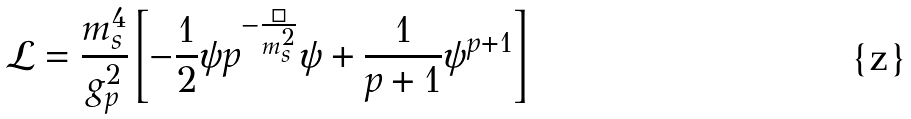<formula> <loc_0><loc_0><loc_500><loc_500>\mathcal { L } = \frac { m _ { s } ^ { 4 } } { g _ { p } ^ { 2 } } \left [ - \frac { 1 } { 2 } \psi p ^ { - \frac { \Box } { m _ { s } ^ { 2 } } } \psi + \frac { 1 } { p + 1 } \psi ^ { p + 1 } \right ]</formula> 